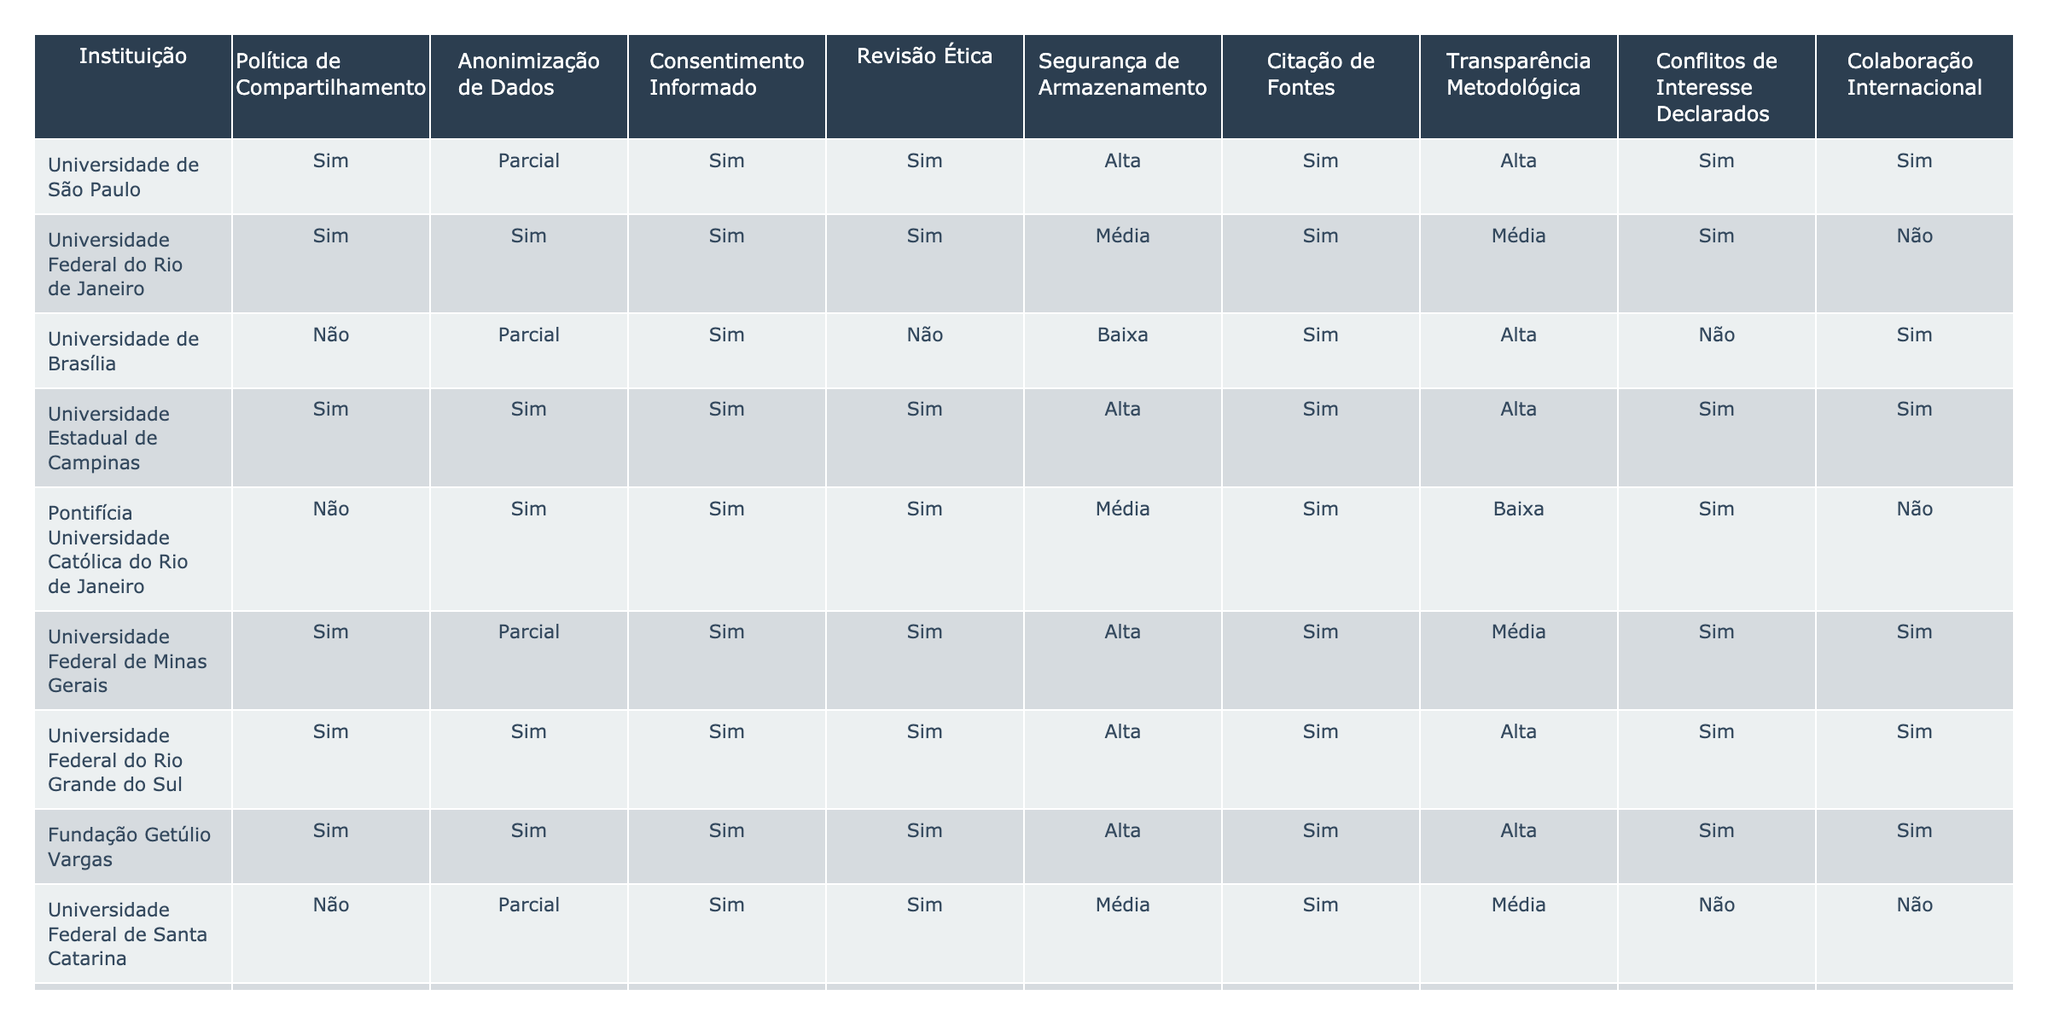Quantas instituições possuem uma política de compartilhamento de dados? Observando a coluna "Política de Compartilhamento", contamos quantas instituições têm "Sim". Das 15 instituições listadas, 10 afirmam ter uma política de compartilhamento de dados.
Answer: 10 Qual instituição tem a maior segurança de armazenamento? Analisando a coluna "Segurança de Armazenamento", classificamos as instituições de acordo com seus níveis: Alta, Média e Baixa. As instituições que recebem 'Alta' incluem Universidade de São Paulo, Universidade Estadual de Campinas, Universidade Federal de Minas Gerais, Universidade Federal do Rio Grande do Sul, Fundação Getúlio Vargas. Portanto, várias instituições estão no topo.
Answer: Várias instituições Quantas instituições não realizam revisão ética? Olhando para a coluna "Revisão Ética", verificamos quantas têm "Não". Das 15 instituições, 3 não realizam revisão ética.
Answer: 3 Quais instituições têm ambas as práticas de anonimização de dados e segurança de armazenamento altas? Verificamos as colunas "Anonimização de Dados" e "Segurança de Armazenamento". Apenas a Universidade Estadual de Campinas, Universidade Federal do Rio Grande do Sul e Fundação Getúlio Vargas têm "Sim" para anonimização e "Alta" para segurança.
Answer: 3 instituições Qual a média do nível de segurança de armazenamento das instituições listadas? A segurança de armazenamento é classificada em três níveis: Alta (2), Média (1) e Baixa (0). Contamos as ocorrências: 6 Altas, 5 Médias e 4 Baixas. Calculamos: (6\*2 + 5\*1 + 4\*0) / 15 = 0.87, o que significa que, em média, as instituições estão entre Média e Alta.
Answer: 0.87 (aproximadamente entre os níveis) A Universidade de Brasília e a Universidade de Fortaleza têm a mesma prática de obscuridade de dados? Ambas as universidades têm "Parcial" na coluna "Anonimização de Dados". Portanto, elas compartilham a mesma prática nesta área.
Answer: Sim Qual é a proporção de instituições que declaram conflitos de interesse em relação ao total? Das 15 instituições listadas, 10 declaram conflitos de interesse (Sim) e 5 não. A proporção é de 10/15 = 0.67.
Answer: 0.67 Qual instituição tem a menor quantidade de práticas éticas seguidas, com base na quantidade de 'Não' nas colunas? Contando as colunas para a Universidade de Brasília, notamos que tem 3 'Não' (Revisão Ética, Segurança de Armazenamento, e Conflitos de Interesse). A Universidade de Fortaleza também tem 3, mas não tem 'Não' em Anonimização. Podemos concluir que a Universidade de Brasília dirige-se como a que segue menos práticas éticas.
Answer: Universidade de Brasília Existem instituições que não possuem uma política de compartilhamento e, ao mesmo tempo, têm segurança de armazenamento baixa? Examinar as linhas de instituições sem política de compartilhamento (Universidade de Brasília, Pontifícia Universidade Católica do Rio de Janeiro, Universidade Federal de Santa Catarina, Universidade Federal da Bahia e Universidade de Fortaleza), notamos que a Universidade de Brasília e a Universidade de Fortaleza têm segurança de armazenamento baixa.
Answer: Sim, duas instituições 